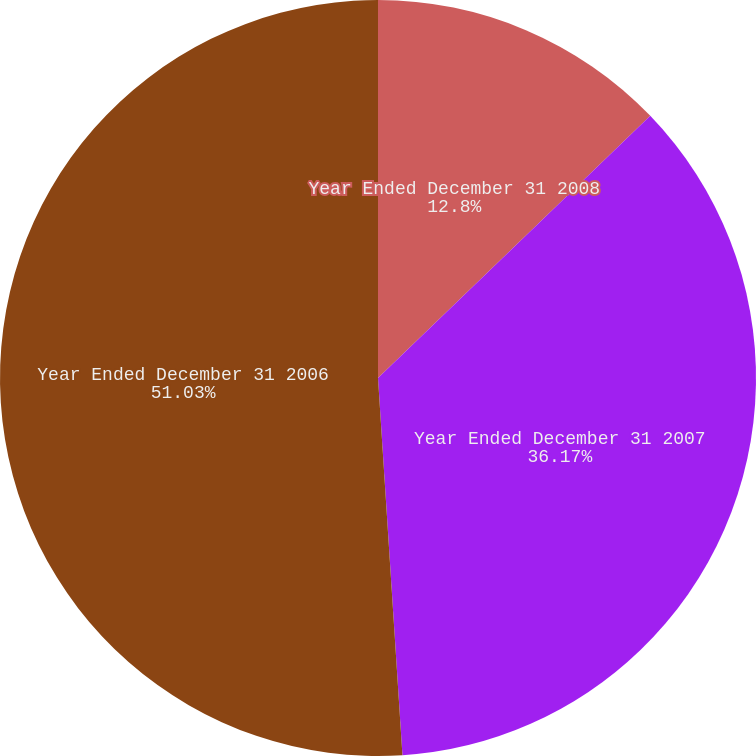<chart> <loc_0><loc_0><loc_500><loc_500><pie_chart><fcel>Year Ended December 31 2008<fcel>Year Ended December 31 2007<fcel>Year Ended December 31 2006<nl><fcel>12.8%<fcel>36.17%<fcel>51.03%<nl></chart> 